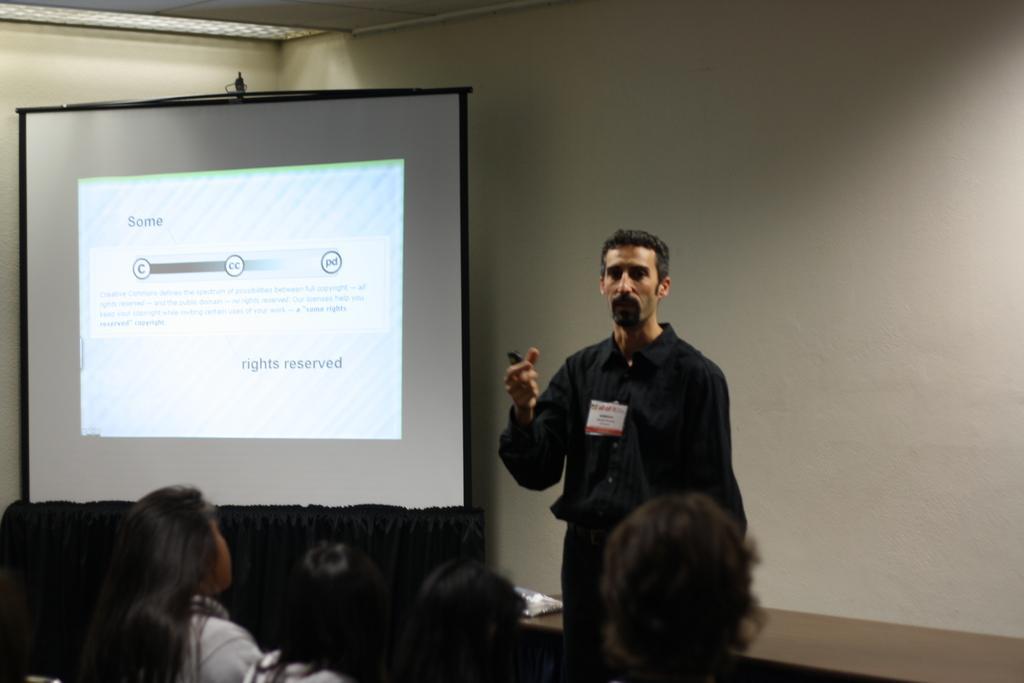How would you summarize this image in a sentence or two? In the picture I can see a person wearing black dress is standing and there are few persons sitting in front of him and there is a projected image in the left corner. 